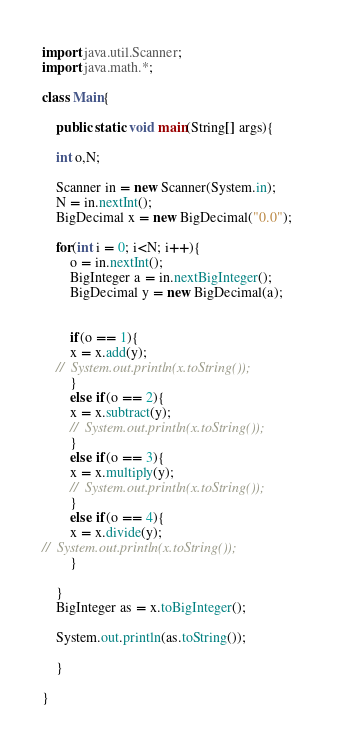Convert code to text. <code><loc_0><loc_0><loc_500><loc_500><_Java_>import java.util.Scanner;
import java.math.*;

class Main{

    public static void main(String[] args){

	int o,N;

	Scanner in = new Scanner(System.in);
	N = in.nextInt();
	BigDecimal x = new BigDecimal("0.0");	

	for(int i = 0; i<N; i++){
	    o = in.nextInt();
	    BigInteger a = in.nextBigInteger();
	    BigDecimal y = new BigDecimal(a);
	   

	    if(o == 1){
		x = x.add(y);
    //	System.out.println(x.toString());
	    }
	    else if(o == 2){
		x = x.subtract(y);
		//	System.out.println(x.toString());
	    }
	    else if(o == 3){
		x = x.multiply(y);
		//	System.out.println(x.toString());
	    }
	    else if(o == 4){
		x = x.divide(y);
//	System.out.println(x.toString());
	    }
	    
	}
	BigInteger as = x.toBigInteger(); 

	System.out.println(as.toString());
       
    }

}</code> 